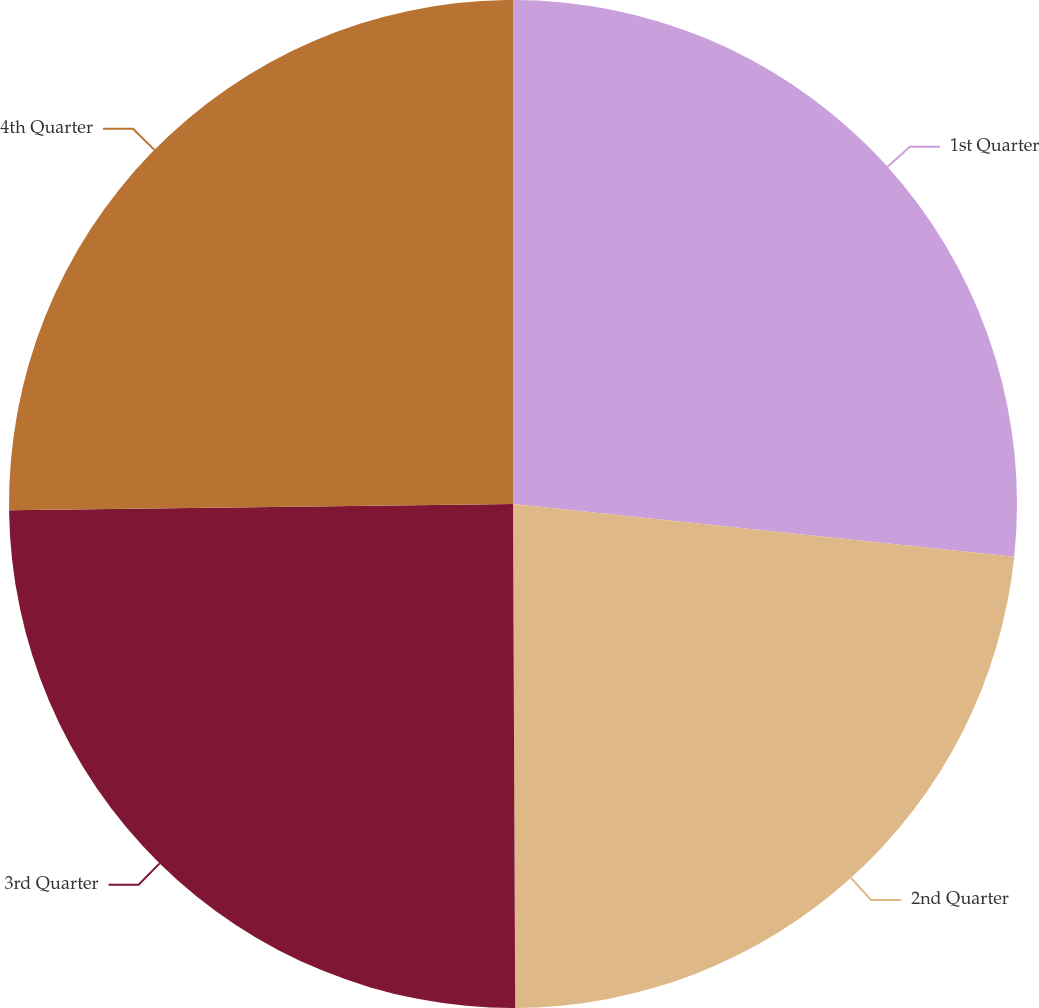Convert chart to OTSL. <chart><loc_0><loc_0><loc_500><loc_500><pie_chart><fcel>1st Quarter<fcel>2nd Quarter<fcel>3rd Quarter<fcel>4th Quarter<nl><fcel>26.67%<fcel>23.26%<fcel>24.87%<fcel>25.2%<nl></chart> 